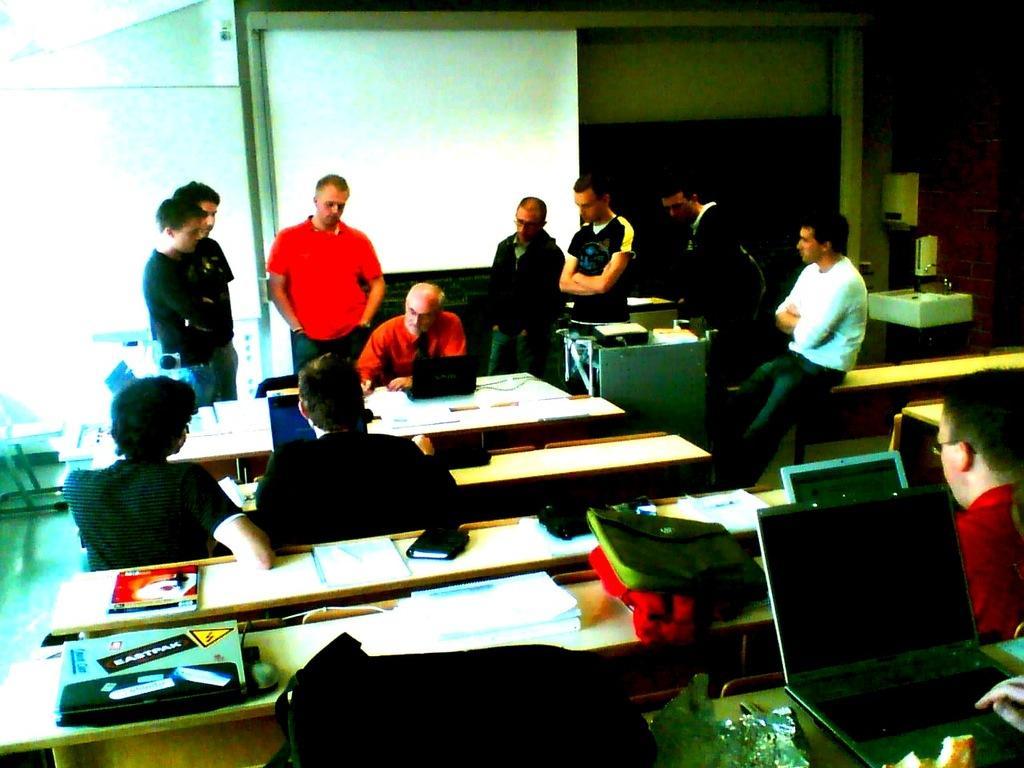Can you describe this image briefly? Few persons are sitting on the chair and few persons standing. We can see laptops,books,papers on the table. On the background we can see wall,screen. This is floor. 